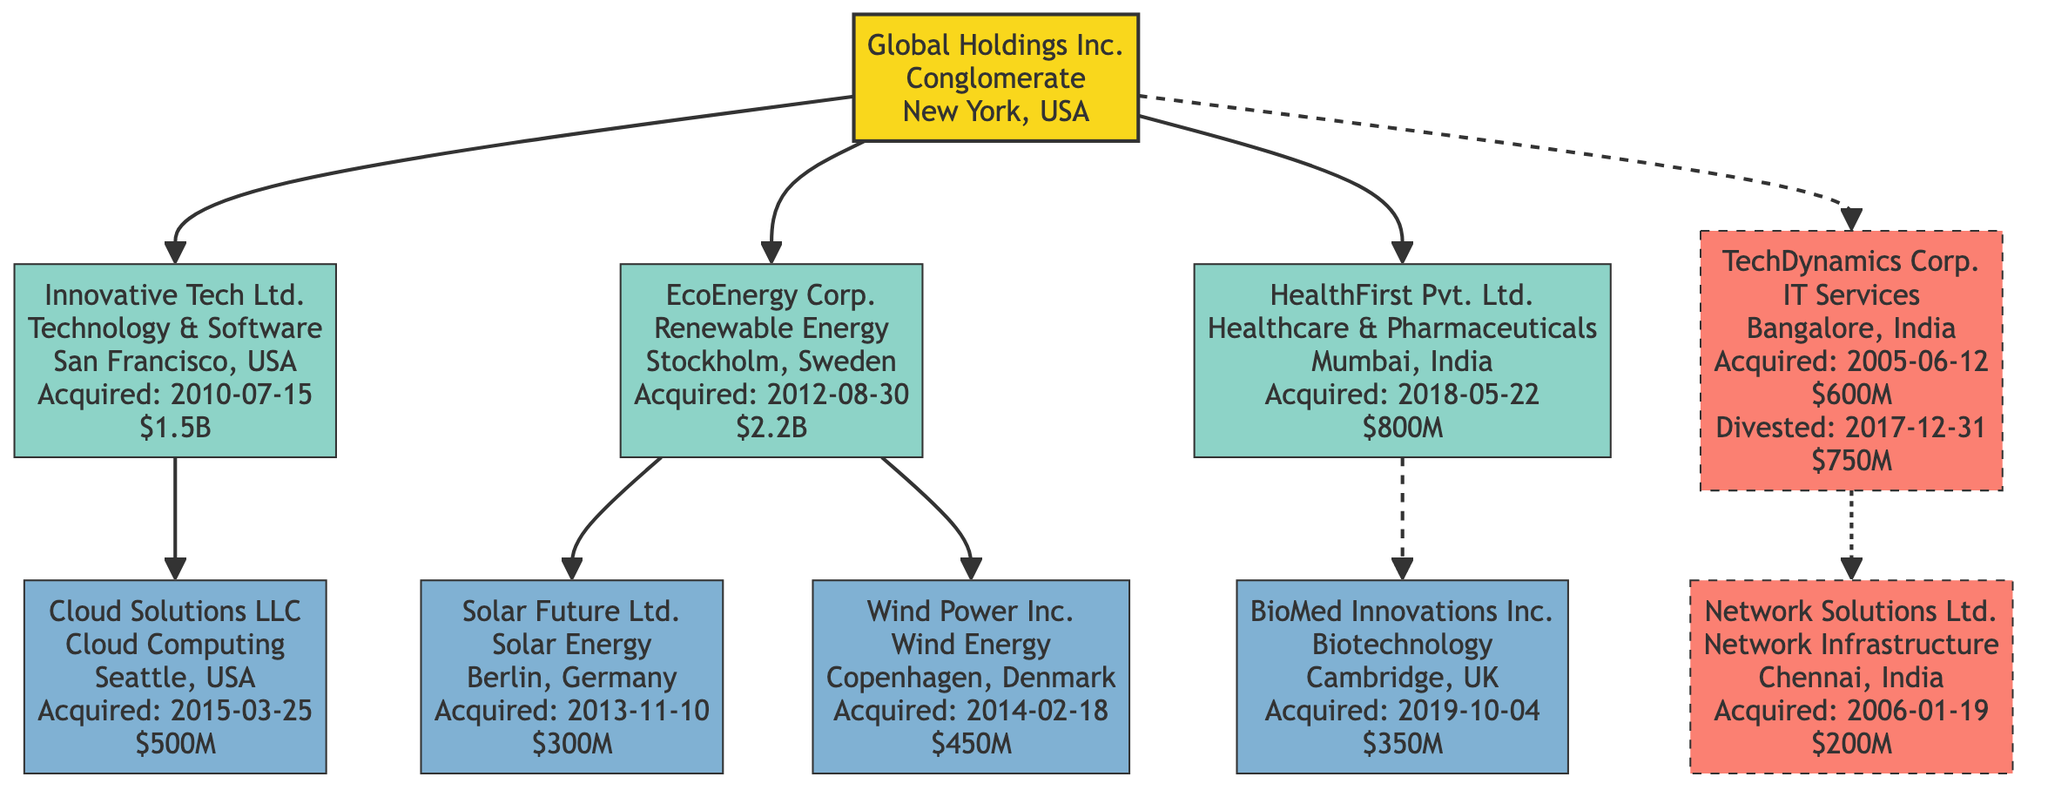What is the acquisition amount for Innovative Tech Ltd.? The diagram shows that Innovative Tech Ltd. was acquired for 1.5 Billion USD.
Answer: 1.5 Billion USD How many subsidiaries does Global Holdings Inc. have? By examining the diagram, Global Holdings Inc. has three direct subsidiaries: Innovative Tech Ltd., EcoEnergy Corp., and HealthFirst Pvt. Ltd.
Answer: 3 Which subsidiary was acquired on August 30, 2012? Looking at the diagram, EcoEnergy Corp. is labeled with the acquisition date of August 30, 2012.
Answer: EcoEnergy Corp What is the industry of the subsidiary Cloud Solutions LLC? The diagram states that Cloud Solutions LLC operates within the Cloud Computing industry.
Answer: Cloud Computing What was the acquisition amount for the historic acquisition TechDynamics Corp.? The diagram indicates that TechDynamics Corp. was acquired for 600 Million USD.
Answer: 600 Million USD How many sub-subsidiaries does EcoEnergy Corp. have? The diagram shows that EcoEnergy Corp. has two sub-subsidiaries: Solar Future Ltd. and Wind Power Inc.
Answer: 2 What is the relationship between Global Holdings Inc. and TechDynamics Corp.? The diagram illustrates that TechDynamics Corp. is a historic acquisition of Global Holdings Inc., indicated by a dashed line.
Answer: Historic acquisition When was BioMed Innovations Inc. acquired? The diagram provides the acquisition date for BioMed Innovations Inc. as October 4, 2019.
Answer: October 4, 2019 What represents the dashed lines in the diagram? The dashed lines in the diagram represent historic acquisitions, indicating relationships that are no longer active but were previously part of the corporate lineage.
Answer: Historic acquisitions 